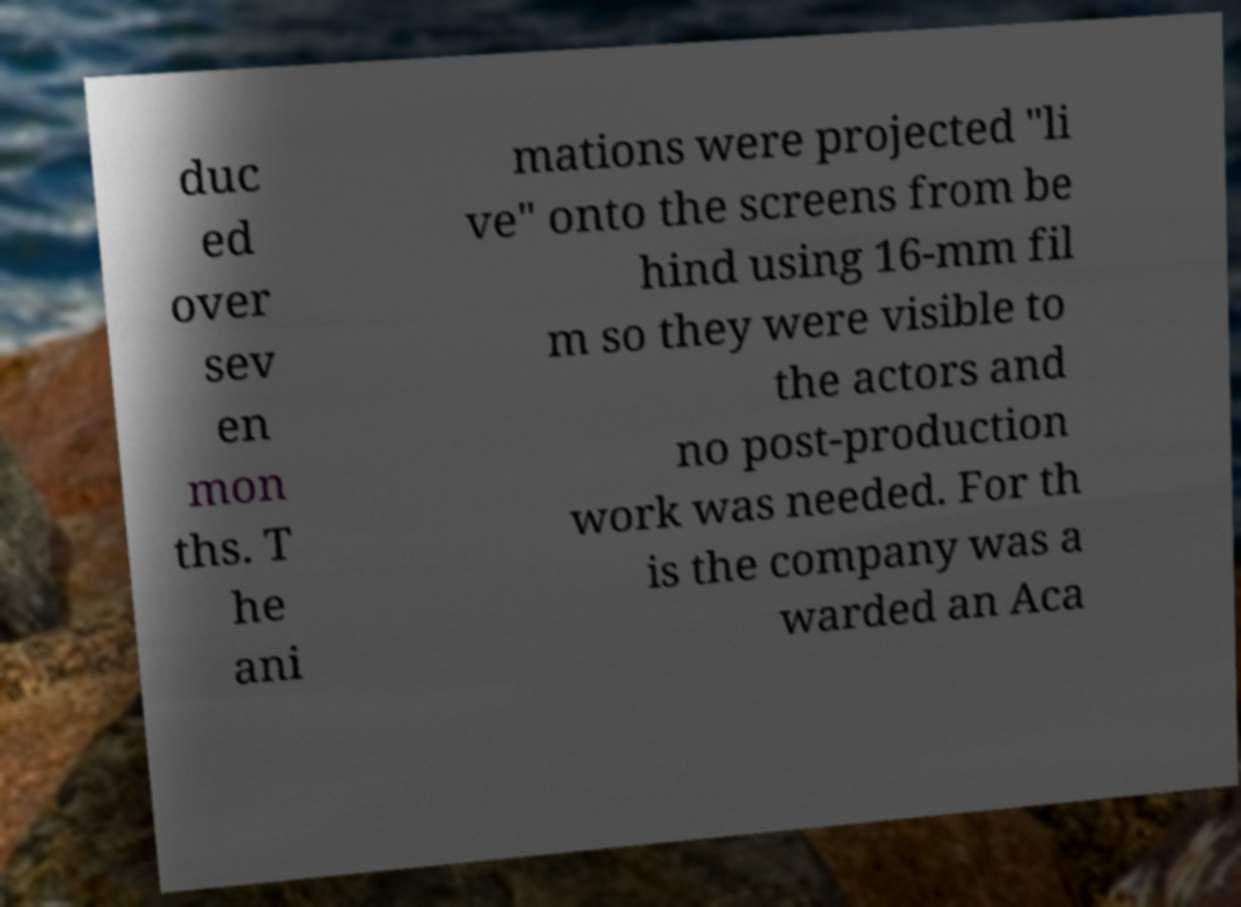I need the written content from this picture converted into text. Can you do that? duc ed over sev en mon ths. T he ani mations were projected "li ve" onto the screens from be hind using 16-mm fil m so they were visible to the actors and no post-production work was needed. For th is the company was a warded an Aca 